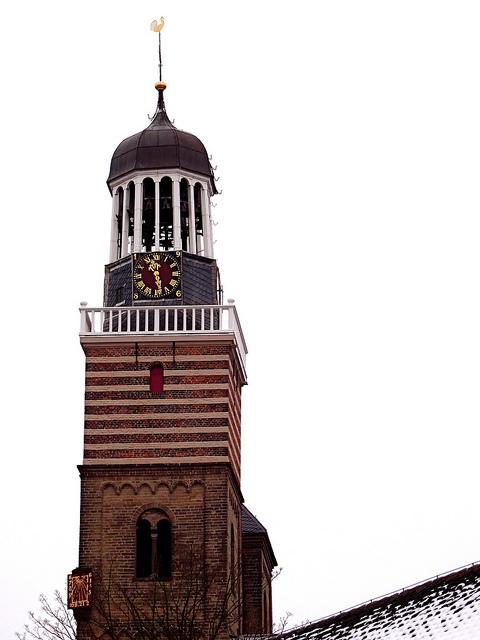Is this night time?
Quick response, please. No. Is there snow on the roof?
Concise answer only. Yes. What time is it?
Give a very brief answer. 11:30. Are the rooftops conic?
Answer briefly. Yes. 